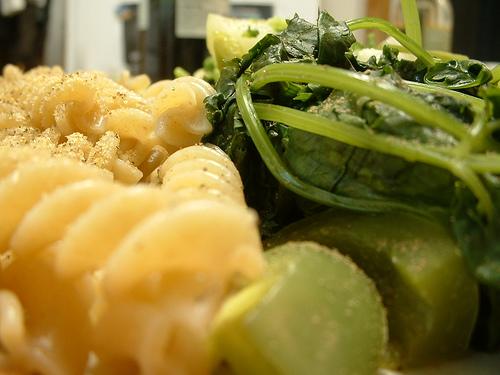What is the yellow food called?
Be succinct. Pasta. What meals is this?
Answer briefly. Dinner. Is the background blurry?
Quick response, please. Yes. 